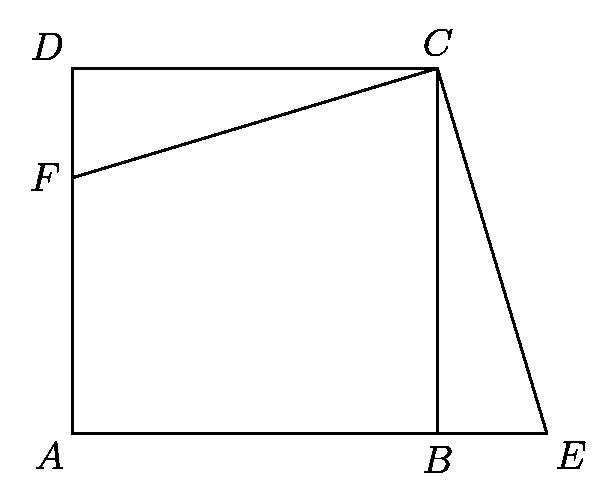What would change in the diagram if point F is moved closer to point D on side AD of the square? Moving point F closer to D would change the slope of line CF, affecting where the perpendicular from C through F intersects the extended line AB at E. This adjustment would alter the length of BE, possibly increasing it, and also change the dimensions and area of triangle CEF. 